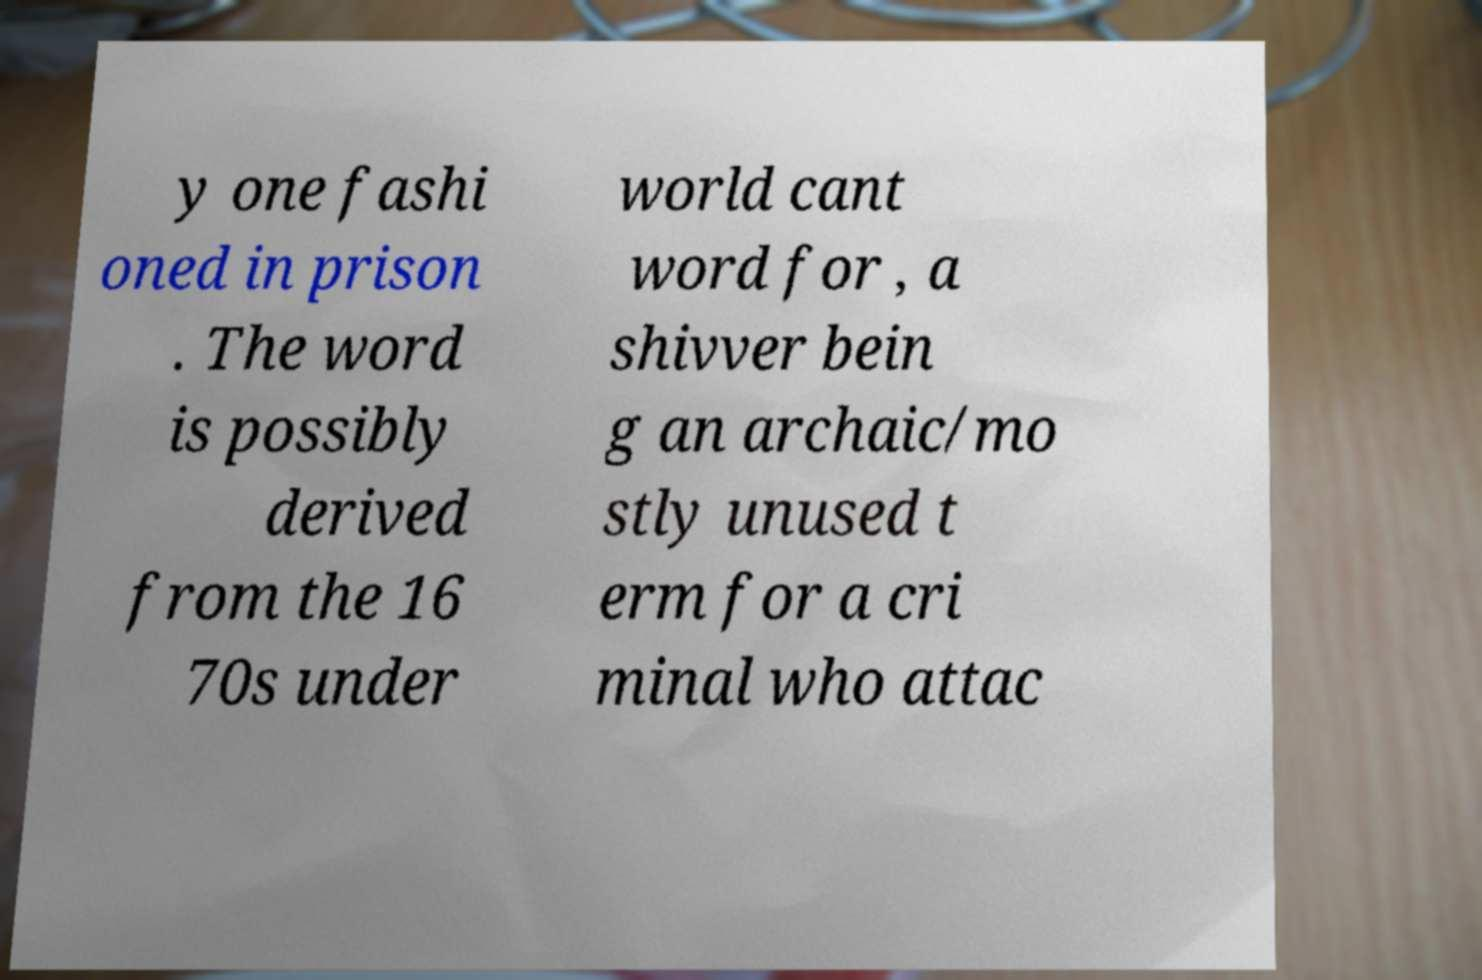What messages or text are displayed in this image? I need them in a readable, typed format. y one fashi oned in prison . The word is possibly derived from the 16 70s under world cant word for , a shivver bein g an archaic/mo stly unused t erm for a cri minal who attac 